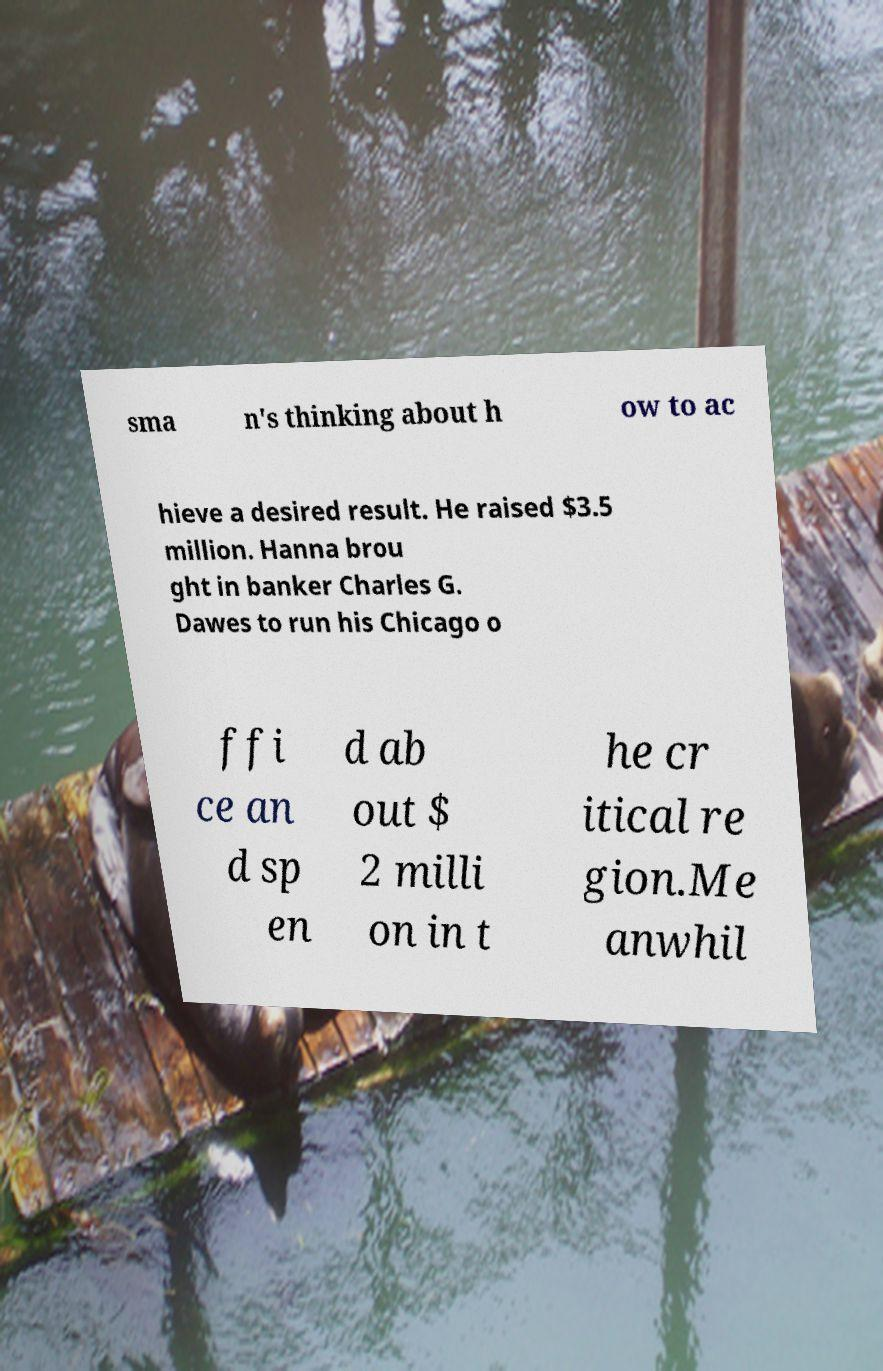Can you read and provide the text displayed in the image?This photo seems to have some interesting text. Can you extract and type it out for me? sma n's thinking about h ow to ac hieve a desired result. He raised $3.5 million. Hanna brou ght in banker Charles G. Dawes to run his Chicago o ffi ce an d sp en d ab out $ 2 milli on in t he cr itical re gion.Me anwhil 